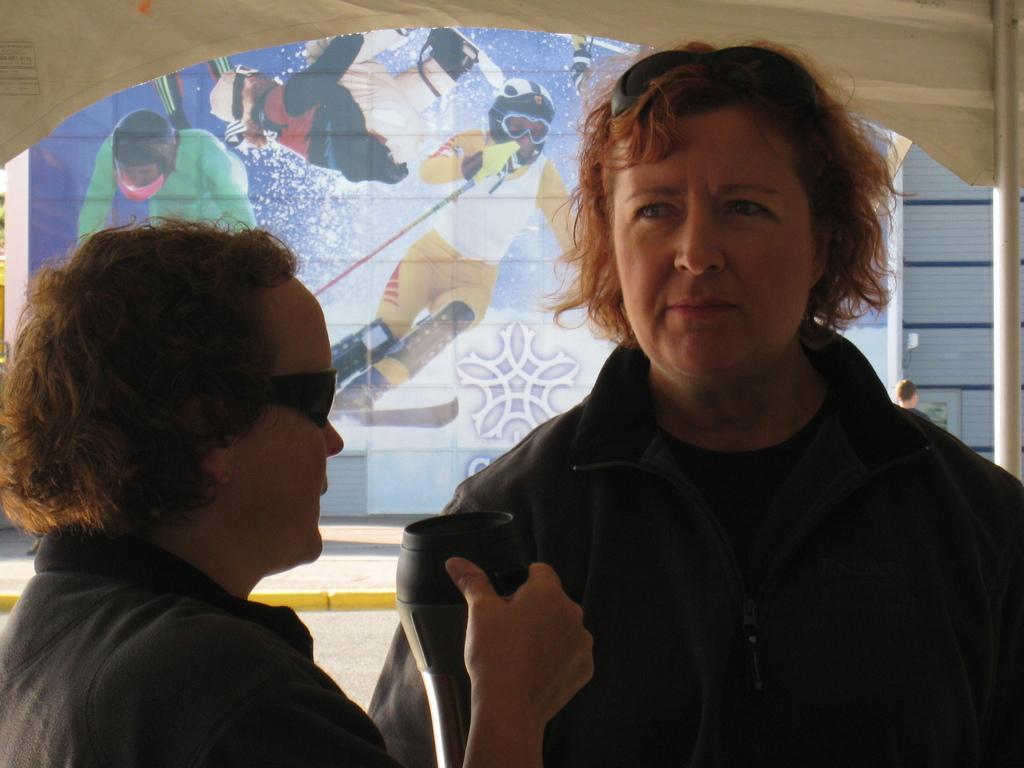How would you summarize this image in a sentence or two? In this picture we can see few people, on the left side of the image we can see a person and the person is holding an object, in the background we can see a hoarding. 